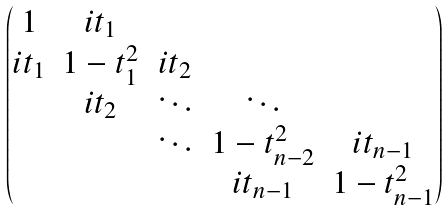<formula> <loc_0><loc_0><loc_500><loc_500>\begin{pmatrix} 1 & i t _ { 1 } & & & \\ i t _ { 1 } & 1 - t _ { 1 } ^ { 2 } & i t _ { 2 } & & \\ & i t _ { 2 } & \ddots & \ddots & \\ & & \ddots & 1 - t _ { n - 2 } ^ { 2 } & i t _ { n - 1 } \\ & & & i t _ { n - 1 } & 1 - t _ { n - 1 } ^ { 2 } \end{pmatrix}</formula> 